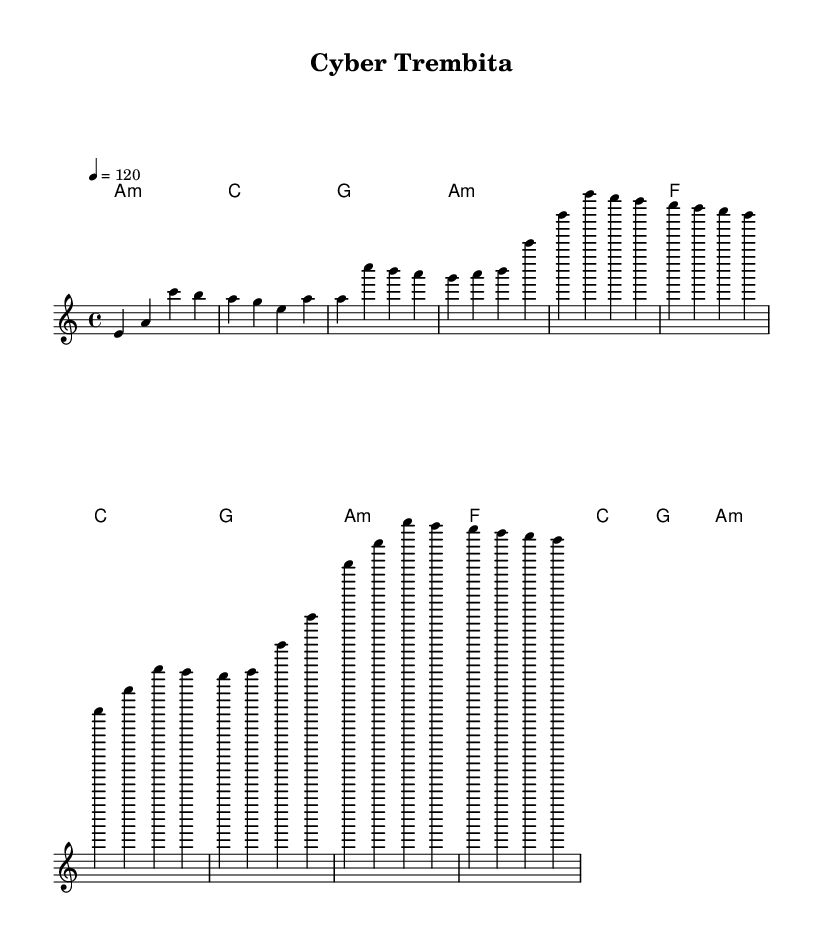What is the key signature of this music? The key signature is A minor, which has no sharps or flats.
Answer: A minor What is the time signature of this piece? The time signature shown in the music is 4/4, indicating four beats per measure.
Answer: 4/4 What is the tempo of the song? The tempo indicated is 120 beats per minute, which gives a moderately fast pace for the music.
Answer: 120 How many measures are in the chorus section? By examining the sheet music, the chorus consists of four measures, identifiable by the pattern of notes and harmonies.
Answer: 4 What type of harmonies does this piece utilize in the verses? The harmonies in the verses include minor and major chords, specifically using A minor, F major, C major, and G major.
Answer: Minor and major chords What is the main melody's starting note? The melody begins on the note E, which is the first note in the introductory section of the piece.
Answer: E How does the melody in the chorus differ from the verse melody? The chorus melody has a more uplifting and dynamic quality, moving through higher notes compared to the verse's more grounded melody.
Answer: Higher notes 